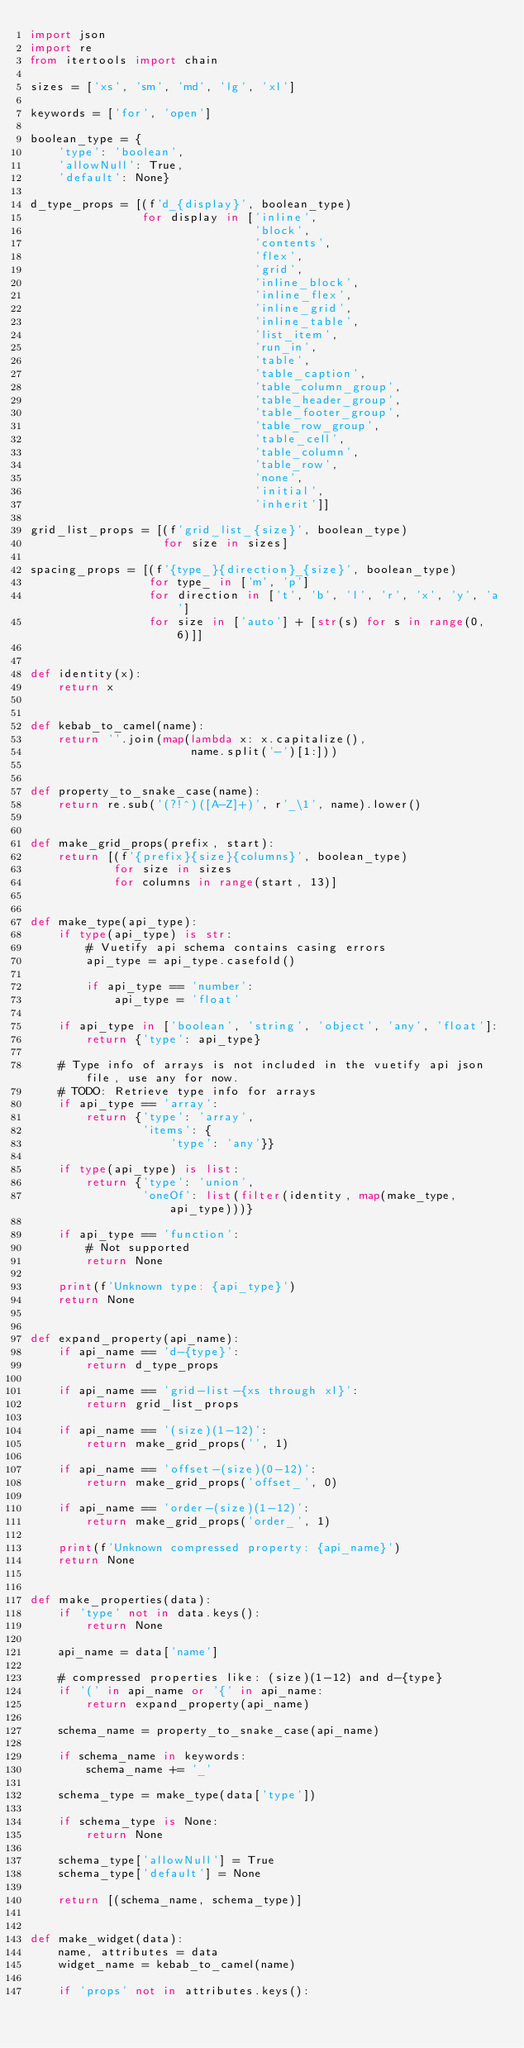Convert code to text. <code><loc_0><loc_0><loc_500><loc_500><_Python_>import json
import re
from itertools import chain

sizes = ['xs', 'sm', 'md', 'lg', 'xl']

keywords = ['for', 'open']

boolean_type = {
    'type': 'boolean',
    'allowNull': True,
    'default': None}

d_type_props = [(f'd_{display}', boolean_type)
                for display in ['inline',
                                'block',
                                'contents',
                                'flex',
                                'grid',
                                'inline_block',
                                'inline_flex',
                                'inline_grid',
                                'inline_table',
                                'list_item',
                                'run_in',
                                'table',
                                'table_caption',
                                'table_column_group',
                                'table_header_group',
                                'table_footer_group',
                                'table_row_group',
                                'table_cell',
                                'table_column',
                                'table_row',
                                'none',
                                'initial',
                                'inherit']]

grid_list_props = [(f'grid_list_{size}', boolean_type)
                   for size in sizes]

spacing_props = [(f'{type_}{direction}_{size}', boolean_type)
                 for type_ in ['m', 'p']
                 for direction in ['t', 'b', 'l', 'r', 'x', 'y', 'a']
                 for size in ['auto'] + [str(s) for s in range(0, 6)]]


def identity(x):
    return x


def kebab_to_camel(name):
    return ''.join(map(lambda x: x.capitalize(),
                       name.split('-')[1:]))


def property_to_snake_case(name):
    return re.sub('(?!^)([A-Z]+)', r'_\1', name).lower()


def make_grid_props(prefix, start):
    return [(f'{prefix}{size}{columns}', boolean_type)
            for size in sizes
            for columns in range(start, 13)]


def make_type(api_type):
    if type(api_type) is str:
        # Vuetify api schema contains casing errors
        api_type = api_type.casefold()

        if api_type == 'number':
            api_type = 'float'

    if api_type in ['boolean', 'string', 'object', 'any', 'float']:
        return {'type': api_type}

    # Type info of arrays is not included in the vuetify api json file, use any for now.
    # TODO: Retrieve type info for arrays
    if api_type == 'array':
        return {'type': 'array',
                'items': {
                    'type': 'any'}}

    if type(api_type) is list:
        return {'type': 'union',
                'oneOf': list(filter(identity, map(make_type, api_type)))}

    if api_type == 'function':
        # Not supported
        return None

    print(f'Unknown type: {api_type}')
    return None


def expand_property(api_name):
    if api_name == 'd-{type}':
        return d_type_props

    if api_name == 'grid-list-{xs through xl}':
        return grid_list_props

    if api_name == '(size)(1-12)':
        return make_grid_props('', 1)

    if api_name == 'offset-(size)(0-12)':
        return make_grid_props('offset_', 0)

    if api_name == 'order-(size)(1-12)':
        return make_grid_props('order_', 1)

    print(f'Unknown compressed property: {api_name}')
    return None


def make_properties(data):
    if 'type' not in data.keys():
        return None

    api_name = data['name']

    # compressed properties like: (size)(1-12) and d-{type}
    if '(' in api_name or '{' in api_name:
        return expand_property(api_name)

    schema_name = property_to_snake_case(api_name)

    if schema_name in keywords:
        schema_name += '_'

    schema_type = make_type(data['type'])

    if schema_type is None:
        return None

    schema_type['allowNull'] = True
    schema_type['default'] = None

    return [(schema_name, schema_type)]


def make_widget(data):
    name, attributes = data
    widget_name = kebab_to_camel(name)

    if 'props' not in attributes.keys():</code> 